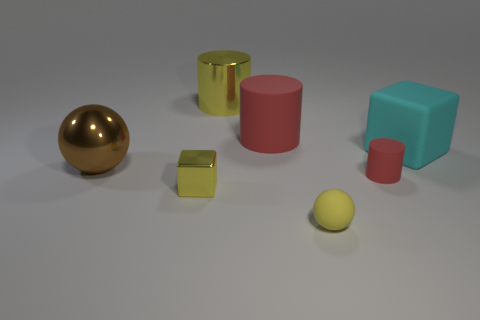Add 3 tiny red things. How many objects exist? 10 Subtract all cylinders. How many objects are left? 4 Add 3 small matte balls. How many small matte balls are left? 4 Add 5 tiny green metallic cubes. How many tiny green metallic cubes exist? 5 Subtract 0 purple cubes. How many objects are left? 7 Subtract all tiny yellow matte balls. Subtract all tiny red metallic objects. How many objects are left? 6 